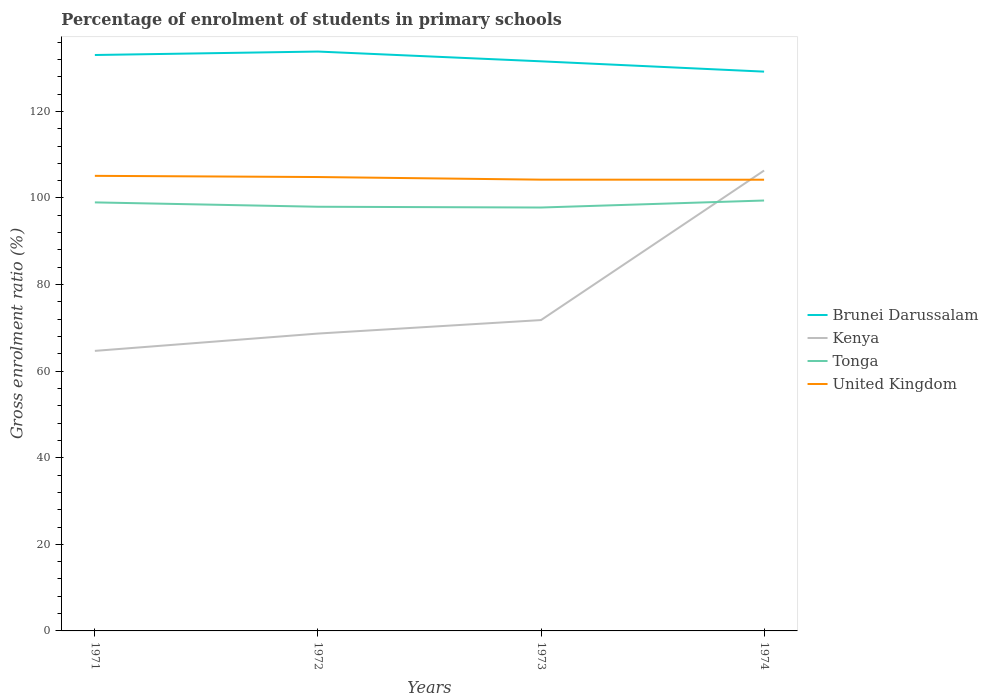How many different coloured lines are there?
Offer a terse response. 4. Does the line corresponding to Tonga intersect with the line corresponding to Brunei Darussalam?
Your answer should be compact. No. Is the number of lines equal to the number of legend labels?
Provide a succinct answer. Yes. Across all years, what is the maximum percentage of students enrolled in primary schools in United Kingdom?
Make the answer very short. 104.22. What is the total percentage of students enrolled in primary schools in Brunei Darussalam in the graph?
Provide a short and direct response. -0.8. What is the difference between the highest and the second highest percentage of students enrolled in primary schools in United Kingdom?
Ensure brevity in your answer.  0.89. How many years are there in the graph?
Make the answer very short. 4. Are the values on the major ticks of Y-axis written in scientific E-notation?
Provide a short and direct response. No. Does the graph contain any zero values?
Offer a very short reply. No. Does the graph contain grids?
Give a very brief answer. No. How many legend labels are there?
Ensure brevity in your answer.  4. How are the legend labels stacked?
Give a very brief answer. Vertical. What is the title of the graph?
Your answer should be very brief. Percentage of enrolment of students in primary schools. What is the Gross enrolment ratio (%) in Brunei Darussalam in 1971?
Make the answer very short. 133.02. What is the Gross enrolment ratio (%) in Kenya in 1971?
Offer a terse response. 64.68. What is the Gross enrolment ratio (%) in Tonga in 1971?
Provide a short and direct response. 98.98. What is the Gross enrolment ratio (%) in United Kingdom in 1971?
Provide a succinct answer. 105.11. What is the Gross enrolment ratio (%) in Brunei Darussalam in 1972?
Keep it short and to the point. 133.82. What is the Gross enrolment ratio (%) of Kenya in 1972?
Your answer should be very brief. 68.68. What is the Gross enrolment ratio (%) in Tonga in 1972?
Offer a terse response. 97.97. What is the Gross enrolment ratio (%) in United Kingdom in 1972?
Provide a succinct answer. 104.84. What is the Gross enrolment ratio (%) of Brunei Darussalam in 1973?
Keep it short and to the point. 131.57. What is the Gross enrolment ratio (%) in Kenya in 1973?
Give a very brief answer. 71.8. What is the Gross enrolment ratio (%) in Tonga in 1973?
Give a very brief answer. 97.8. What is the Gross enrolment ratio (%) of United Kingdom in 1973?
Your answer should be very brief. 104.23. What is the Gross enrolment ratio (%) in Brunei Darussalam in 1974?
Make the answer very short. 129.18. What is the Gross enrolment ratio (%) of Kenya in 1974?
Ensure brevity in your answer.  106.34. What is the Gross enrolment ratio (%) in Tonga in 1974?
Provide a short and direct response. 99.41. What is the Gross enrolment ratio (%) of United Kingdom in 1974?
Make the answer very short. 104.22. Across all years, what is the maximum Gross enrolment ratio (%) of Brunei Darussalam?
Your answer should be very brief. 133.82. Across all years, what is the maximum Gross enrolment ratio (%) in Kenya?
Provide a short and direct response. 106.34. Across all years, what is the maximum Gross enrolment ratio (%) in Tonga?
Your response must be concise. 99.41. Across all years, what is the maximum Gross enrolment ratio (%) in United Kingdom?
Offer a terse response. 105.11. Across all years, what is the minimum Gross enrolment ratio (%) in Brunei Darussalam?
Your answer should be compact. 129.18. Across all years, what is the minimum Gross enrolment ratio (%) of Kenya?
Make the answer very short. 64.68. Across all years, what is the minimum Gross enrolment ratio (%) in Tonga?
Ensure brevity in your answer.  97.8. Across all years, what is the minimum Gross enrolment ratio (%) of United Kingdom?
Offer a terse response. 104.22. What is the total Gross enrolment ratio (%) of Brunei Darussalam in the graph?
Offer a very short reply. 527.59. What is the total Gross enrolment ratio (%) in Kenya in the graph?
Keep it short and to the point. 311.5. What is the total Gross enrolment ratio (%) in Tonga in the graph?
Ensure brevity in your answer.  394.16. What is the total Gross enrolment ratio (%) in United Kingdom in the graph?
Keep it short and to the point. 418.4. What is the difference between the Gross enrolment ratio (%) of Brunei Darussalam in 1971 and that in 1972?
Keep it short and to the point. -0.8. What is the difference between the Gross enrolment ratio (%) in Kenya in 1971 and that in 1972?
Provide a succinct answer. -4. What is the difference between the Gross enrolment ratio (%) of Tonga in 1971 and that in 1972?
Provide a short and direct response. 1.01. What is the difference between the Gross enrolment ratio (%) in United Kingdom in 1971 and that in 1972?
Offer a very short reply. 0.27. What is the difference between the Gross enrolment ratio (%) in Brunei Darussalam in 1971 and that in 1973?
Your answer should be compact. 1.46. What is the difference between the Gross enrolment ratio (%) in Kenya in 1971 and that in 1973?
Your answer should be compact. -7.11. What is the difference between the Gross enrolment ratio (%) of Tonga in 1971 and that in 1973?
Offer a terse response. 1.18. What is the difference between the Gross enrolment ratio (%) of United Kingdom in 1971 and that in 1973?
Your response must be concise. 0.88. What is the difference between the Gross enrolment ratio (%) of Brunei Darussalam in 1971 and that in 1974?
Provide a succinct answer. 3.84. What is the difference between the Gross enrolment ratio (%) in Kenya in 1971 and that in 1974?
Make the answer very short. -41.65. What is the difference between the Gross enrolment ratio (%) in Tonga in 1971 and that in 1974?
Provide a succinct answer. -0.43. What is the difference between the Gross enrolment ratio (%) of United Kingdom in 1971 and that in 1974?
Provide a short and direct response. 0.89. What is the difference between the Gross enrolment ratio (%) in Brunei Darussalam in 1972 and that in 1973?
Your answer should be compact. 2.26. What is the difference between the Gross enrolment ratio (%) of Kenya in 1972 and that in 1973?
Offer a terse response. -3.12. What is the difference between the Gross enrolment ratio (%) in Tonga in 1972 and that in 1973?
Make the answer very short. 0.17. What is the difference between the Gross enrolment ratio (%) in United Kingdom in 1972 and that in 1973?
Keep it short and to the point. 0.61. What is the difference between the Gross enrolment ratio (%) in Brunei Darussalam in 1972 and that in 1974?
Your answer should be compact. 4.64. What is the difference between the Gross enrolment ratio (%) in Kenya in 1972 and that in 1974?
Give a very brief answer. -37.66. What is the difference between the Gross enrolment ratio (%) in Tonga in 1972 and that in 1974?
Keep it short and to the point. -1.44. What is the difference between the Gross enrolment ratio (%) in United Kingdom in 1972 and that in 1974?
Your response must be concise. 0.62. What is the difference between the Gross enrolment ratio (%) of Brunei Darussalam in 1973 and that in 1974?
Make the answer very short. 2.38. What is the difference between the Gross enrolment ratio (%) in Kenya in 1973 and that in 1974?
Provide a succinct answer. -34.54. What is the difference between the Gross enrolment ratio (%) in Tonga in 1973 and that in 1974?
Provide a short and direct response. -1.62. What is the difference between the Gross enrolment ratio (%) in United Kingdom in 1973 and that in 1974?
Your answer should be very brief. 0.01. What is the difference between the Gross enrolment ratio (%) of Brunei Darussalam in 1971 and the Gross enrolment ratio (%) of Kenya in 1972?
Offer a very short reply. 64.34. What is the difference between the Gross enrolment ratio (%) in Brunei Darussalam in 1971 and the Gross enrolment ratio (%) in Tonga in 1972?
Give a very brief answer. 35.05. What is the difference between the Gross enrolment ratio (%) of Brunei Darussalam in 1971 and the Gross enrolment ratio (%) of United Kingdom in 1972?
Your answer should be compact. 28.18. What is the difference between the Gross enrolment ratio (%) in Kenya in 1971 and the Gross enrolment ratio (%) in Tonga in 1972?
Provide a succinct answer. -33.29. What is the difference between the Gross enrolment ratio (%) in Kenya in 1971 and the Gross enrolment ratio (%) in United Kingdom in 1972?
Make the answer very short. -40.15. What is the difference between the Gross enrolment ratio (%) in Tonga in 1971 and the Gross enrolment ratio (%) in United Kingdom in 1972?
Your answer should be very brief. -5.86. What is the difference between the Gross enrolment ratio (%) of Brunei Darussalam in 1971 and the Gross enrolment ratio (%) of Kenya in 1973?
Provide a succinct answer. 61.22. What is the difference between the Gross enrolment ratio (%) in Brunei Darussalam in 1971 and the Gross enrolment ratio (%) in Tonga in 1973?
Make the answer very short. 35.23. What is the difference between the Gross enrolment ratio (%) in Brunei Darussalam in 1971 and the Gross enrolment ratio (%) in United Kingdom in 1973?
Make the answer very short. 28.79. What is the difference between the Gross enrolment ratio (%) in Kenya in 1971 and the Gross enrolment ratio (%) in Tonga in 1973?
Your answer should be compact. -33.11. What is the difference between the Gross enrolment ratio (%) of Kenya in 1971 and the Gross enrolment ratio (%) of United Kingdom in 1973?
Your answer should be very brief. -39.55. What is the difference between the Gross enrolment ratio (%) in Tonga in 1971 and the Gross enrolment ratio (%) in United Kingdom in 1973?
Ensure brevity in your answer.  -5.25. What is the difference between the Gross enrolment ratio (%) in Brunei Darussalam in 1971 and the Gross enrolment ratio (%) in Kenya in 1974?
Ensure brevity in your answer.  26.68. What is the difference between the Gross enrolment ratio (%) of Brunei Darussalam in 1971 and the Gross enrolment ratio (%) of Tonga in 1974?
Ensure brevity in your answer.  33.61. What is the difference between the Gross enrolment ratio (%) of Brunei Darussalam in 1971 and the Gross enrolment ratio (%) of United Kingdom in 1974?
Your answer should be very brief. 28.8. What is the difference between the Gross enrolment ratio (%) in Kenya in 1971 and the Gross enrolment ratio (%) in Tonga in 1974?
Provide a short and direct response. -34.73. What is the difference between the Gross enrolment ratio (%) of Kenya in 1971 and the Gross enrolment ratio (%) of United Kingdom in 1974?
Your answer should be compact. -39.53. What is the difference between the Gross enrolment ratio (%) of Tonga in 1971 and the Gross enrolment ratio (%) of United Kingdom in 1974?
Make the answer very short. -5.24. What is the difference between the Gross enrolment ratio (%) in Brunei Darussalam in 1972 and the Gross enrolment ratio (%) in Kenya in 1973?
Offer a terse response. 62.02. What is the difference between the Gross enrolment ratio (%) of Brunei Darussalam in 1972 and the Gross enrolment ratio (%) of Tonga in 1973?
Give a very brief answer. 36.03. What is the difference between the Gross enrolment ratio (%) in Brunei Darussalam in 1972 and the Gross enrolment ratio (%) in United Kingdom in 1973?
Offer a terse response. 29.59. What is the difference between the Gross enrolment ratio (%) in Kenya in 1972 and the Gross enrolment ratio (%) in Tonga in 1973?
Provide a short and direct response. -29.11. What is the difference between the Gross enrolment ratio (%) in Kenya in 1972 and the Gross enrolment ratio (%) in United Kingdom in 1973?
Make the answer very short. -35.55. What is the difference between the Gross enrolment ratio (%) in Tonga in 1972 and the Gross enrolment ratio (%) in United Kingdom in 1973?
Keep it short and to the point. -6.26. What is the difference between the Gross enrolment ratio (%) of Brunei Darussalam in 1972 and the Gross enrolment ratio (%) of Kenya in 1974?
Your response must be concise. 27.48. What is the difference between the Gross enrolment ratio (%) of Brunei Darussalam in 1972 and the Gross enrolment ratio (%) of Tonga in 1974?
Make the answer very short. 34.41. What is the difference between the Gross enrolment ratio (%) of Brunei Darussalam in 1972 and the Gross enrolment ratio (%) of United Kingdom in 1974?
Provide a short and direct response. 29.6. What is the difference between the Gross enrolment ratio (%) of Kenya in 1972 and the Gross enrolment ratio (%) of Tonga in 1974?
Your answer should be compact. -30.73. What is the difference between the Gross enrolment ratio (%) of Kenya in 1972 and the Gross enrolment ratio (%) of United Kingdom in 1974?
Offer a very short reply. -35.54. What is the difference between the Gross enrolment ratio (%) of Tonga in 1972 and the Gross enrolment ratio (%) of United Kingdom in 1974?
Ensure brevity in your answer.  -6.25. What is the difference between the Gross enrolment ratio (%) in Brunei Darussalam in 1973 and the Gross enrolment ratio (%) in Kenya in 1974?
Ensure brevity in your answer.  25.23. What is the difference between the Gross enrolment ratio (%) in Brunei Darussalam in 1973 and the Gross enrolment ratio (%) in Tonga in 1974?
Ensure brevity in your answer.  32.15. What is the difference between the Gross enrolment ratio (%) in Brunei Darussalam in 1973 and the Gross enrolment ratio (%) in United Kingdom in 1974?
Ensure brevity in your answer.  27.35. What is the difference between the Gross enrolment ratio (%) of Kenya in 1973 and the Gross enrolment ratio (%) of Tonga in 1974?
Give a very brief answer. -27.61. What is the difference between the Gross enrolment ratio (%) in Kenya in 1973 and the Gross enrolment ratio (%) in United Kingdom in 1974?
Offer a terse response. -32.42. What is the difference between the Gross enrolment ratio (%) in Tonga in 1973 and the Gross enrolment ratio (%) in United Kingdom in 1974?
Provide a succinct answer. -6.42. What is the average Gross enrolment ratio (%) of Brunei Darussalam per year?
Give a very brief answer. 131.9. What is the average Gross enrolment ratio (%) in Kenya per year?
Offer a terse response. 77.88. What is the average Gross enrolment ratio (%) in Tonga per year?
Make the answer very short. 98.54. What is the average Gross enrolment ratio (%) of United Kingdom per year?
Make the answer very short. 104.6. In the year 1971, what is the difference between the Gross enrolment ratio (%) of Brunei Darussalam and Gross enrolment ratio (%) of Kenya?
Your answer should be compact. 68.34. In the year 1971, what is the difference between the Gross enrolment ratio (%) in Brunei Darussalam and Gross enrolment ratio (%) in Tonga?
Provide a short and direct response. 34.04. In the year 1971, what is the difference between the Gross enrolment ratio (%) in Brunei Darussalam and Gross enrolment ratio (%) in United Kingdom?
Your answer should be compact. 27.91. In the year 1971, what is the difference between the Gross enrolment ratio (%) of Kenya and Gross enrolment ratio (%) of Tonga?
Offer a terse response. -34.3. In the year 1971, what is the difference between the Gross enrolment ratio (%) of Kenya and Gross enrolment ratio (%) of United Kingdom?
Offer a very short reply. -40.43. In the year 1971, what is the difference between the Gross enrolment ratio (%) in Tonga and Gross enrolment ratio (%) in United Kingdom?
Make the answer very short. -6.13. In the year 1972, what is the difference between the Gross enrolment ratio (%) in Brunei Darussalam and Gross enrolment ratio (%) in Kenya?
Offer a terse response. 65.14. In the year 1972, what is the difference between the Gross enrolment ratio (%) of Brunei Darussalam and Gross enrolment ratio (%) of Tonga?
Your answer should be very brief. 35.85. In the year 1972, what is the difference between the Gross enrolment ratio (%) in Brunei Darussalam and Gross enrolment ratio (%) in United Kingdom?
Provide a short and direct response. 28.98. In the year 1972, what is the difference between the Gross enrolment ratio (%) in Kenya and Gross enrolment ratio (%) in Tonga?
Offer a very short reply. -29.29. In the year 1972, what is the difference between the Gross enrolment ratio (%) in Kenya and Gross enrolment ratio (%) in United Kingdom?
Your answer should be compact. -36.16. In the year 1972, what is the difference between the Gross enrolment ratio (%) in Tonga and Gross enrolment ratio (%) in United Kingdom?
Provide a short and direct response. -6.87. In the year 1973, what is the difference between the Gross enrolment ratio (%) of Brunei Darussalam and Gross enrolment ratio (%) of Kenya?
Offer a very short reply. 59.77. In the year 1973, what is the difference between the Gross enrolment ratio (%) of Brunei Darussalam and Gross enrolment ratio (%) of Tonga?
Offer a very short reply. 33.77. In the year 1973, what is the difference between the Gross enrolment ratio (%) in Brunei Darussalam and Gross enrolment ratio (%) in United Kingdom?
Make the answer very short. 27.34. In the year 1973, what is the difference between the Gross enrolment ratio (%) in Kenya and Gross enrolment ratio (%) in Tonga?
Provide a short and direct response. -26. In the year 1973, what is the difference between the Gross enrolment ratio (%) of Kenya and Gross enrolment ratio (%) of United Kingdom?
Your answer should be compact. -32.43. In the year 1973, what is the difference between the Gross enrolment ratio (%) of Tonga and Gross enrolment ratio (%) of United Kingdom?
Your response must be concise. -6.43. In the year 1974, what is the difference between the Gross enrolment ratio (%) in Brunei Darussalam and Gross enrolment ratio (%) in Kenya?
Give a very brief answer. 22.85. In the year 1974, what is the difference between the Gross enrolment ratio (%) in Brunei Darussalam and Gross enrolment ratio (%) in Tonga?
Keep it short and to the point. 29.77. In the year 1974, what is the difference between the Gross enrolment ratio (%) of Brunei Darussalam and Gross enrolment ratio (%) of United Kingdom?
Offer a very short reply. 24.97. In the year 1974, what is the difference between the Gross enrolment ratio (%) in Kenya and Gross enrolment ratio (%) in Tonga?
Offer a terse response. 6.93. In the year 1974, what is the difference between the Gross enrolment ratio (%) in Kenya and Gross enrolment ratio (%) in United Kingdom?
Your answer should be compact. 2.12. In the year 1974, what is the difference between the Gross enrolment ratio (%) of Tonga and Gross enrolment ratio (%) of United Kingdom?
Provide a short and direct response. -4.81. What is the ratio of the Gross enrolment ratio (%) of Kenya in 1971 to that in 1972?
Provide a short and direct response. 0.94. What is the ratio of the Gross enrolment ratio (%) of Tonga in 1971 to that in 1972?
Provide a succinct answer. 1.01. What is the ratio of the Gross enrolment ratio (%) in United Kingdom in 1971 to that in 1972?
Keep it short and to the point. 1. What is the ratio of the Gross enrolment ratio (%) in Brunei Darussalam in 1971 to that in 1973?
Provide a short and direct response. 1.01. What is the ratio of the Gross enrolment ratio (%) of Kenya in 1971 to that in 1973?
Provide a succinct answer. 0.9. What is the ratio of the Gross enrolment ratio (%) in Tonga in 1971 to that in 1973?
Give a very brief answer. 1.01. What is the ratio of the Gross enrolment ratio (%) in United Kingdom in 1971 to that in 1973?
Make the answer very short. 1.01. What is the ratio of the Gross enrolment ratio (%) of Brunei Darussalam in 1971 to that in 1974?
Make the answer very short. 1.03. What is the ratio of the Gross enrolment ratio (%) of Kenya in 1971 to that in 1974?
Provide a succinct answer. 0.61. What is the ratio of the Gross enrolment ratio (%) in United Kingdom in 1971 to that in 1974?
Your answer should be compact. 1.01. What is the ratio of the Gross enrolment ratio (%) of Brunei Darussalam in 1972 to that in 1973?
Make the answer very short. 1.02. What is the ratio of the Gross enrolment ratio (%) of Kenya in 1972 to that in 1973?
Offer a terse response. 0.96. What is the ratio of the Gross enrolment ratio (%) of Brunei Darussalam in 1972 to that in 1974?
Provide a succinct answer. 1.04. What is the ratio of the Gross enrolment ratio (%) of Kenya in 1972 to that in 1974?
Provide a succinct answer. 0.65. What is the ratio of the Gross enrolment ratio (%) of Tonga in 1972 to that in 1974?
Offer a very short reply. 0.99. What is the ratio of the Gross enrolment ratio (%) in United Kingdom in 1972 to that in 1974?
Give a very brief answer. 1.01. What is the ratio of the Gross enrolment ratio (%) of Brunei Darussalam in 1973 to that in 1974?
Make the answer very short. 1.02. What is the ratio of the Gross enrolment ratio (%) in Kenya in 1973 to that in 1974?
Give a very brief answer. 0.68. What is the ratio of the Gross enrolment ratio (%) in Tonga in 1973 to that in 1974?
Give a very brief answer. 0.98. What is the ratio of the Gross enrolment ratio (%) in United Kingdom in 1973 to that in 1974?
Make the answer very short. 1. What is the difference between the highest and the second highest Gross enrolment ratio (%) of Brunei Darussalam?
Keep it short and to the point. 0.8. What is the difference between the highest and the second highest Gross enrolment ratio (%) in Kenya?
Provide a short and direct response. 34.54. What is the difference between the highest and the second highest Gross enrolment ratio (%) of Tonga?
Your answer should be compact. 0.43. What is the difference between the highest and the second highest Gross enrolment ratio (%) of United Kingdom?
Provide a short and direct response. 0.27. What is the difference between the highest and the lowest Gross enrolment ratio (%) of Brunei Darussalam?
Offer a very short reply. 4.64. What is the difference between the highest and the lowest Gross enrolment ratio (%) of Kenya?
Your answer should be very brief. 41.65. What is the difference between the highest and the lowest Gross enrolment ratio (%) of Tonga?
Your answer should be compact. 1.62. What is the difference between the highest and the lowest Gross enrolment ratio (%) of United Kingdom?
Provide a short and direct response. 0.89. 